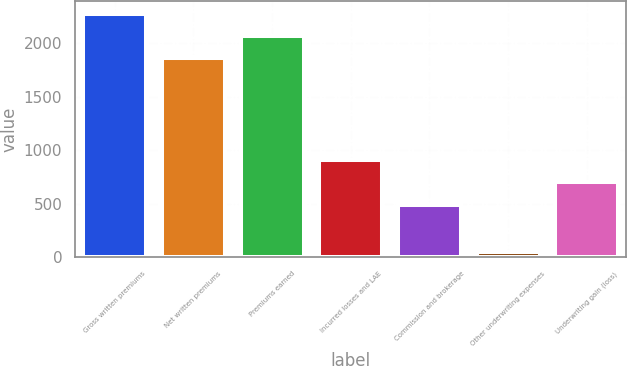Convert chart to OTSL. <chart><loc_0><loc_0><loc_500><loc_500><bar_chart><fcel>Gross written premiums<fcel>Net written premiums<fcel>Premiums earned<fcel>Incurred losses and LAE<fcel>Commission and brokerage<fcel>Other underwriting expenses<fcel>Underwriting gain (loss)<nl><fcel>2275.46<fcel>1855.9<fcel>2065.68<fcel>912.86<fcel>493.3<fcel>50.1<fcel>703.08<nl></chart> 